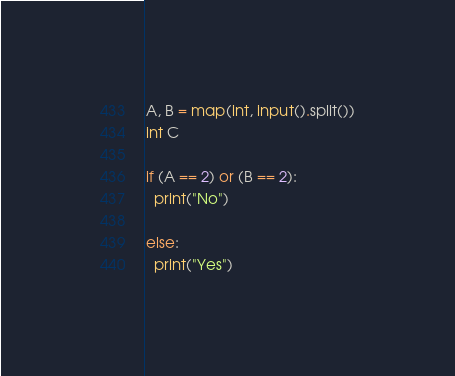Convert code to text. <code><loc_0><loc_0><loc_500><loc_500><_Python_>A, B = map(int, input().split())
int C

if (A == 2) or (B == 2):
  print("No")
  
else:
  print("Yes")</code> 